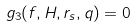<formula> <loc_0><loc_0><loc_500><loc_500>g _ { 3 } ( f , H , r _ { s } , q ) = 0</formula> 